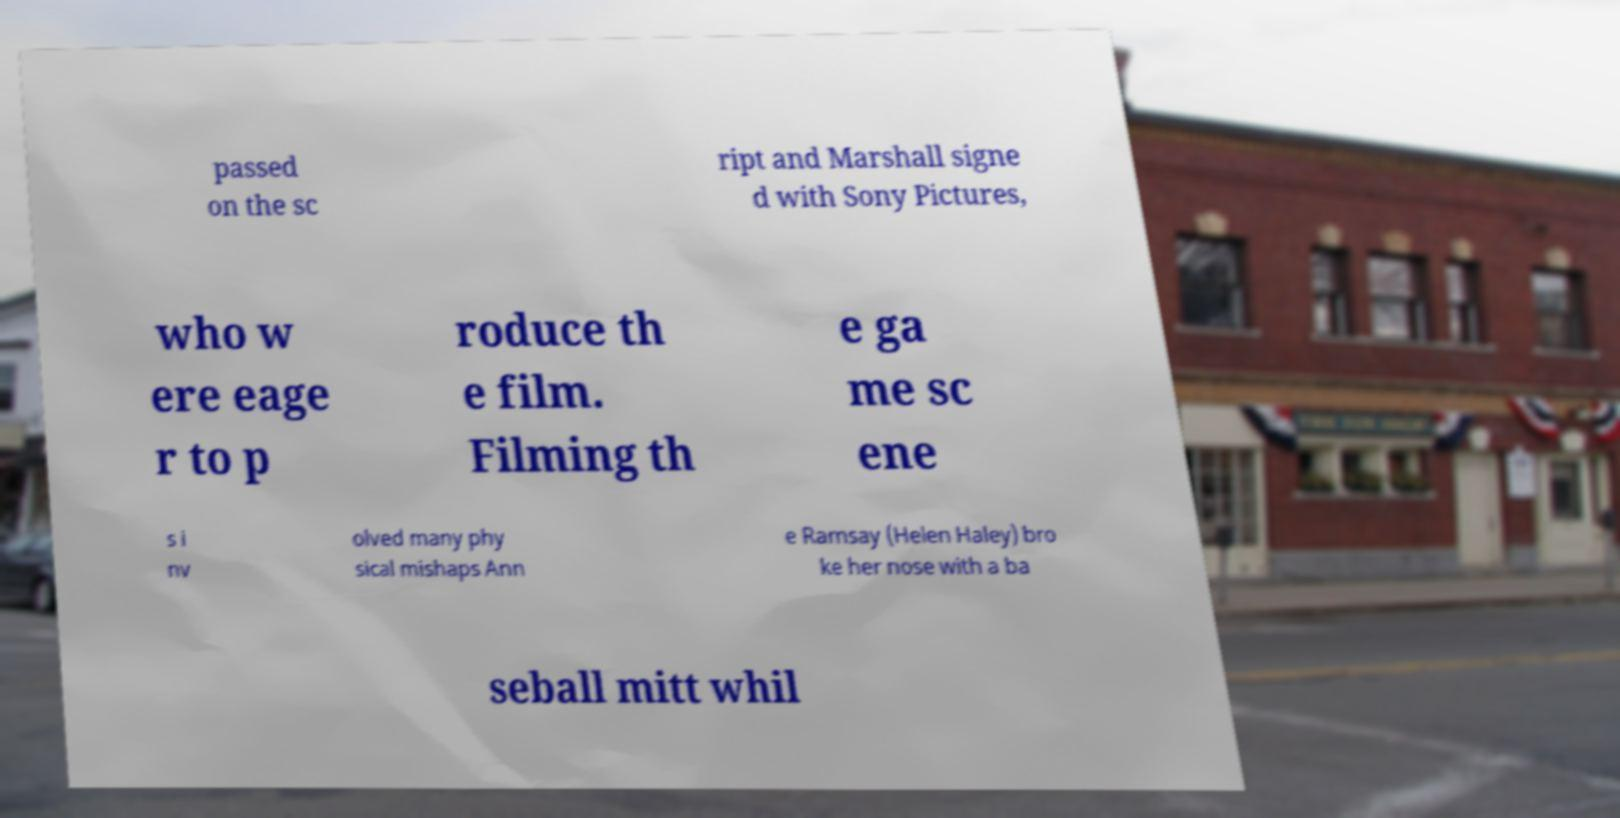Could you assist in decoding the text presented in this image and type it out clearly? passed on the sc ript and Marshall signe d with Sony Pictures, who w ere eage r to p roduce th e film. Filming th e ga me sc ene s i nv olved many phy sical mishaps Ann e Ramsay (Helen Haley) bro ke her nose with a ba seball mitt whil 